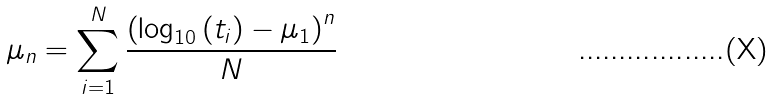Convert formula to latex. <formula><loc_0><loc_0><loc_500><loc_500>\mu _ { n } = \sum _ { i = 1 } ^ { N } \frac { \left ( \log _ { 1 0 } \left ( t _ { i } \right ) - \mu _ { 1 } \right ) ^ { n } } { N }</formula> 